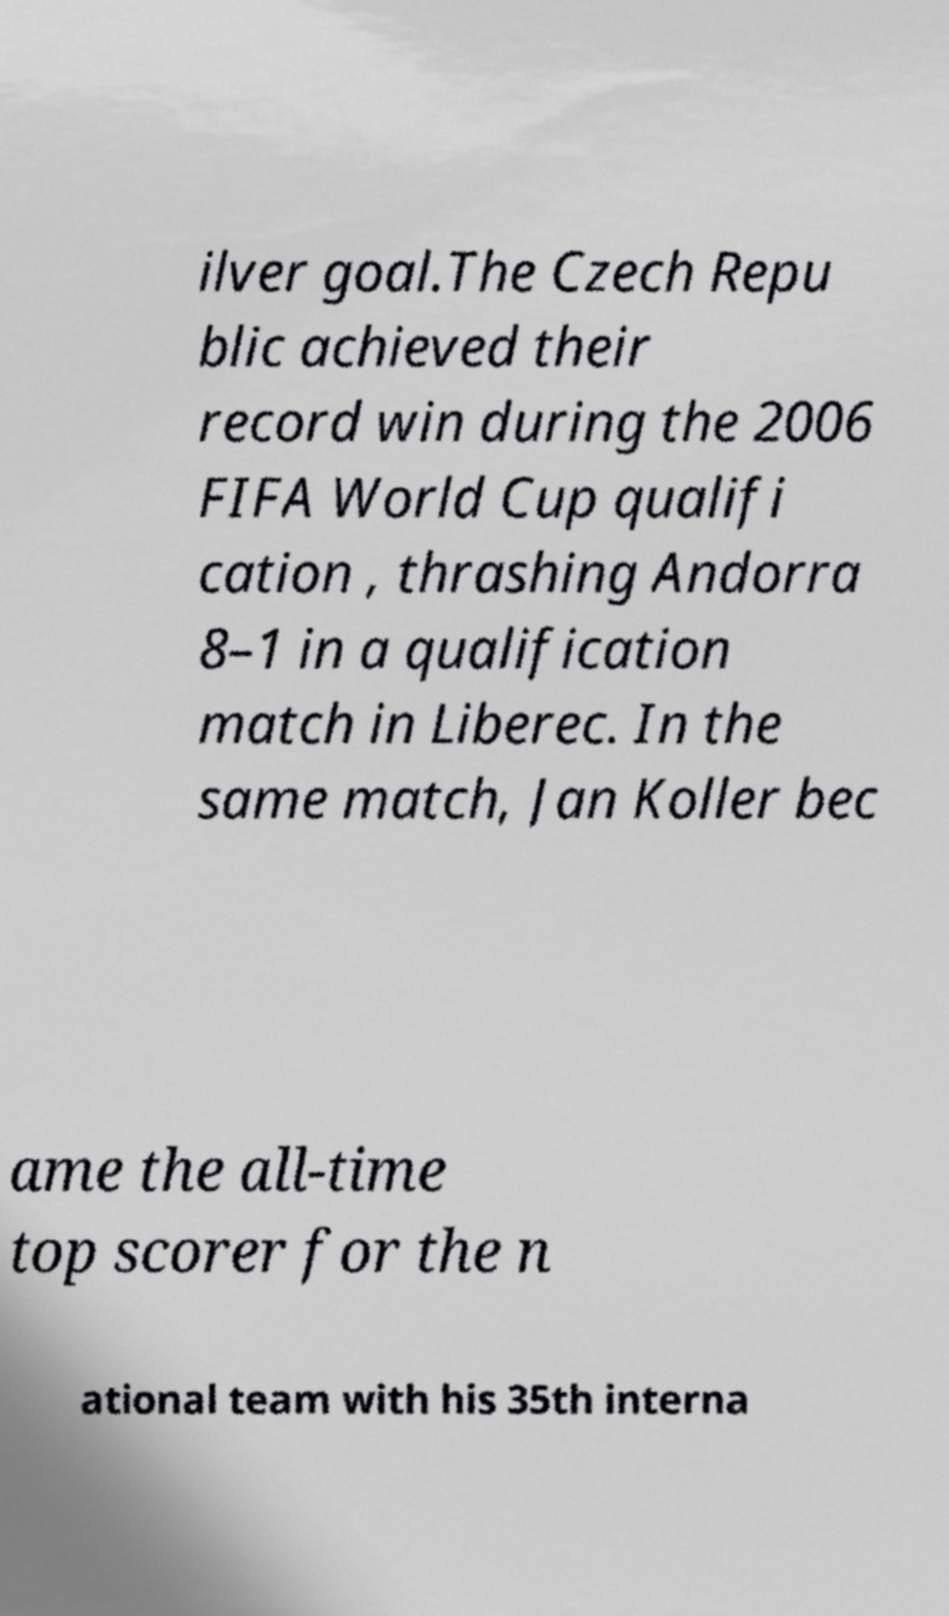There's text embedded in this image that I need extracted. Can you transcribe it verbatim? ilver goal.The Czech Repu blic achieved their record win during the 2006 FIFA World Cup qualifi cation , thrashing Andorra 8–1 in a qualification match in Liberec. In the same match, Jan Koller bec ame the all-time top scorer for the n ational team with his 35th interna 